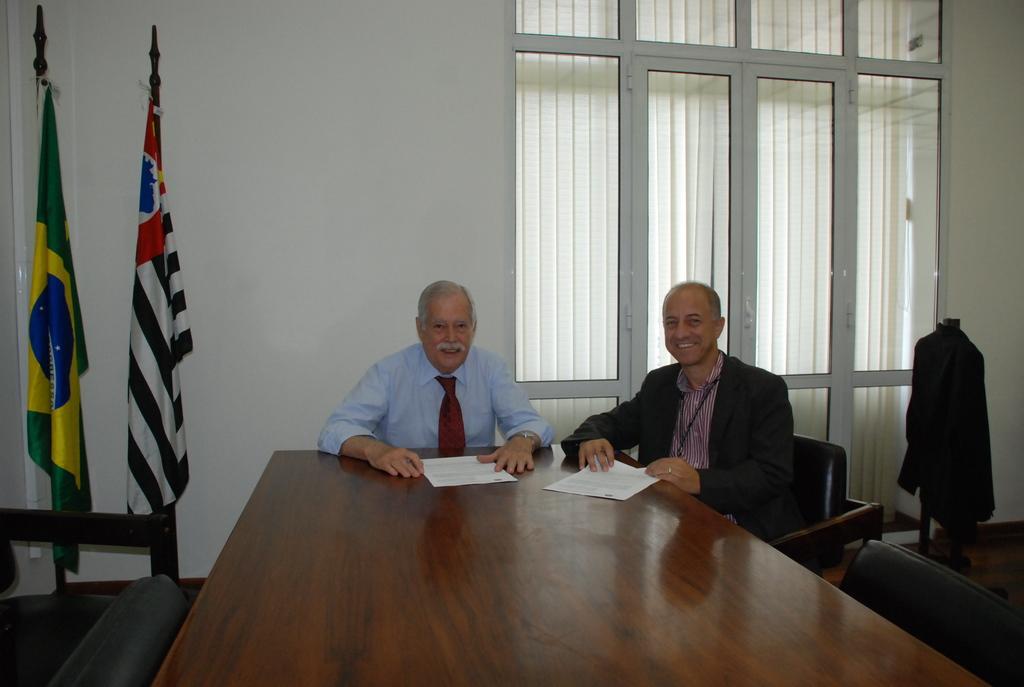Could you give a brief overview of what you see in this image? There are sitting in the chairs in front of the table on which some papers were there. In the left side there are two national flags. In the background there are some windows and a wall here. 